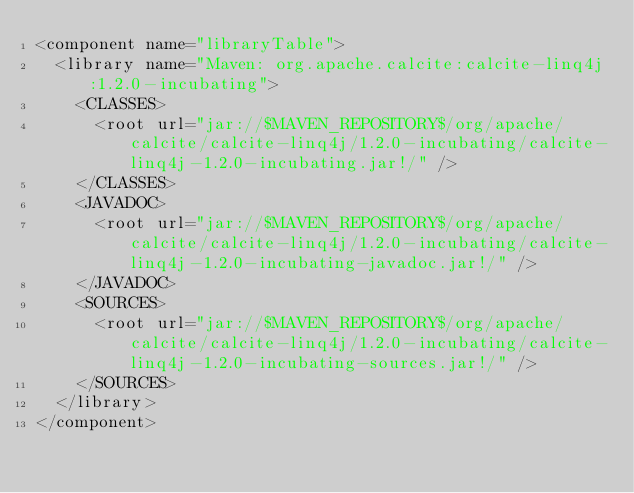<code> <loc_0><loc_0><loc_500><loc_500><_XML_><component name="libraryTable">
  <library name="Maven: org.apache.calcite:calcite-linq4j:1.2.0-incubating">
    <CLASSES>
      <root url="jar://$MAVEN_REPOSITORY$/org/apache/calcite/calcite-linq4j/1.2.0-incubating/calcite-linq4j-1.2.0-incubating.jar!/" />
    </CLASSES>
    <JAVADOC>
      <root url="jar://$MAVEN_REPOSITORY$/org/apache/calcite/calcite-linq4j/1.2.0-incubating/calcite-linq4j-1.2.0-incubating-javadoc.jar!/" />
    </JAVADOC>
    <SOURCES>
      <root url="jar://$MAVEN_REPOSITORY$/org/apache/calcite/calcite-linq4j/1.2.0-incubating/calcite-linq4j-1.2.0-incubating-sources.jar!/" />
    </SOURCES>
  </library>
</component></code> 